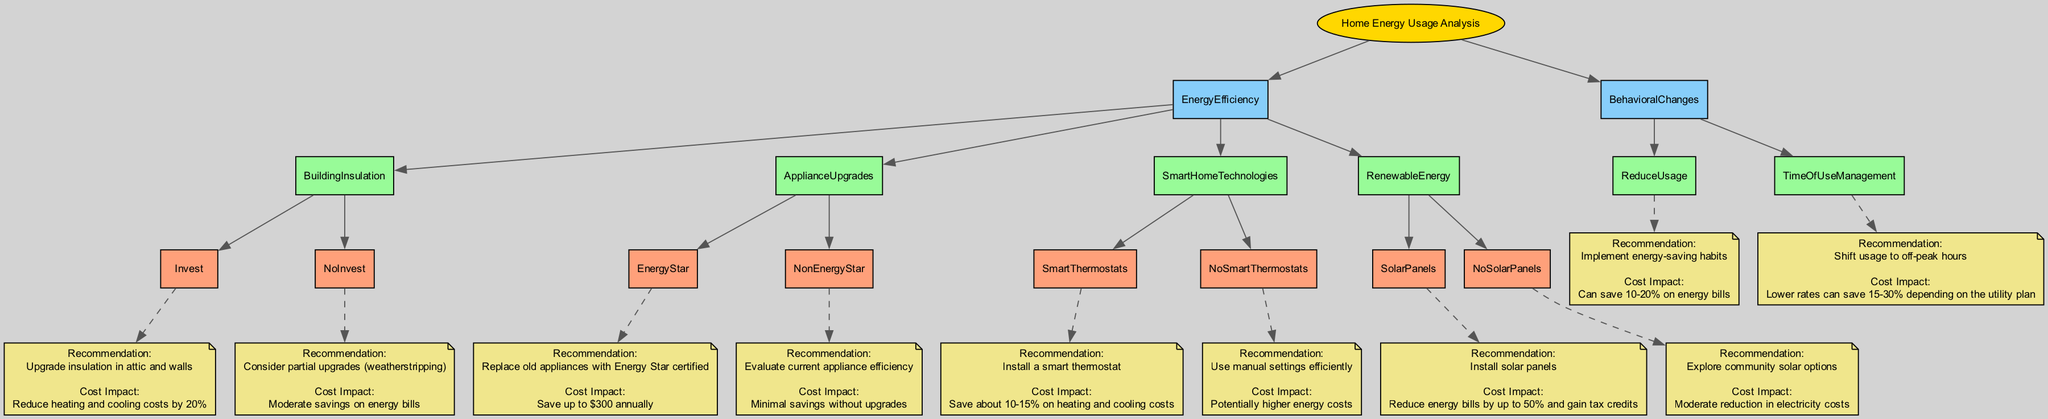What are the main categories in the decision tree? The main categories in the decision tree are Energy Efficiency and Behavioral Changes. Each category represents a significant aspect of home energy usage that can be analyzed for cost-saving opportunities.
Answer: Energy Efficiency, Behavioral Changes What is the cost impact of installing solar panels? The cost impact of installing solar panels is a reduction in energy bills by up to 50% and gaining tax credits, as indicated in the Renewable Energy section.
Answer: Reduce energy bills by up to 50% and gain tax credits How many options are available under Energy Efficiency? There are four options available under Energy Efficiency: Building Insulation, Appliance Upgrades, Smart Home Technologies, and Renewable Energy. Each option provides different methods to enhance energy efficiency in the home.
Answer: 4 What is the recommendation if one does not invest in building insulation? If one does not invest in building insulation, the recommendation is to consider partial upgrades such as weatherstripping. This recommendation is meant to provide a more cost-effective approach to improving home energy efficiency while still achieving some savings.
Answer: Consider partial upgrades (weatherstripping) What are the potential savings from shifting usage to off-peak hours? Shifting usage to off-peak hours can save 15-30% depending on the utility plan. This is a strategy made to optimize energy cost savings by utilizing lower rates during times of reduced energy demand.
Answer: Lower rates can save 15-30% What happens if one chooses to evaluate current appliance efficiency instead of upgrading to Energy Star appliances? If one evaluates current appliance efficiency and opts not to upgrade to Energy Star appliances, there are minimal savings without upgrades. This indicates that while some efficiencies might be found, they are often not substantial enough to justify avoiding the replacement of older appliances with high-efficiency models.
Answer: Minimal savings without upgrades What is the overall impact of implementing energy-saving habits? Implementing energy-saving habits can lead to savings of 10-20% on energy bills. This suggests that simple changes in daily habits can significantly affect overall energy efficiency and cost reduction.
Answer: Can save 10-20% on energy bills What type of thermostat should one install for optimal savings? One should install a smart thermostat for optimal savings, which can save about 10-15% on heating and cooling costs. This recommendation points towards utilizing advanced technology to enhance energy management in the home.
Answer: Install a smart thermostat What is the recommendation for users who do not have smart thermostats? The recommendation for those who do not have smart thermostats is to use manual settings efficiently. This advice suggests that even without modern technology, being mindful of energy usage can still help manage costs effectively.
Answer: Use manual settings efficiently 